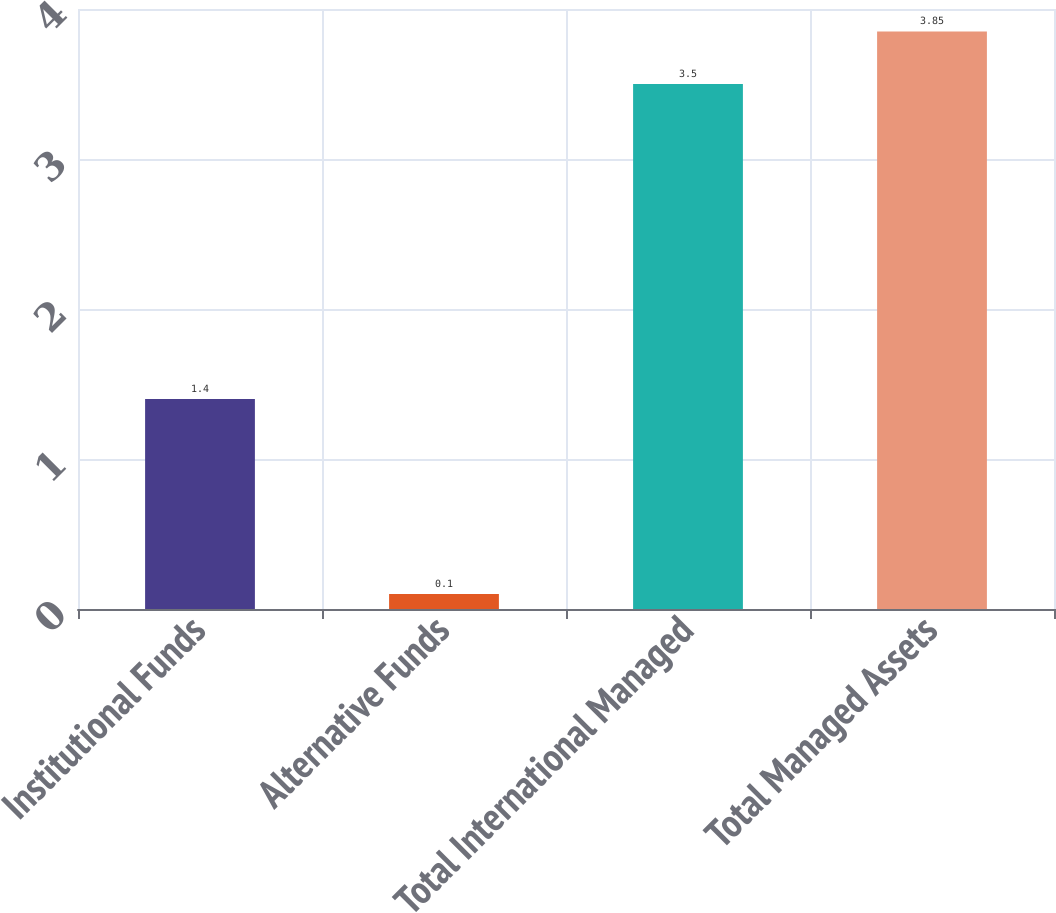<chart> <loc_0><loc_0><loc_500><loc_500><bar_chart><fcel>Institutional Funds<fcel>Alternative Funds<fcel>Total International Managed<fcel>Total Managed Assets<nl><fcel>1.4<fcel>0.1<fcel>3.5<fcel>3.85<nl></chart> 